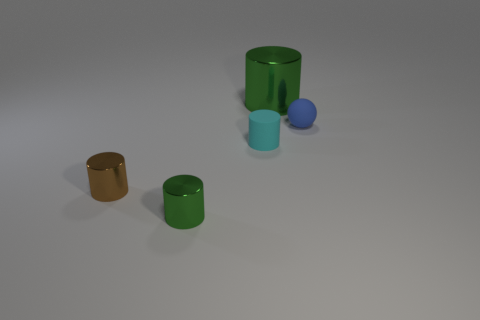What could be the size of these objects in relation to each other? Relative to each other, the objects vary in size. Highlighting two similar shapes, the green cylinders show a clear size difference, with one considerably larger than the other. The blue sphere is the smallest object, and the teal cylinder is of medium size. The size differences and variety suggest these objects could be used to demonstrate scale or proportions. 